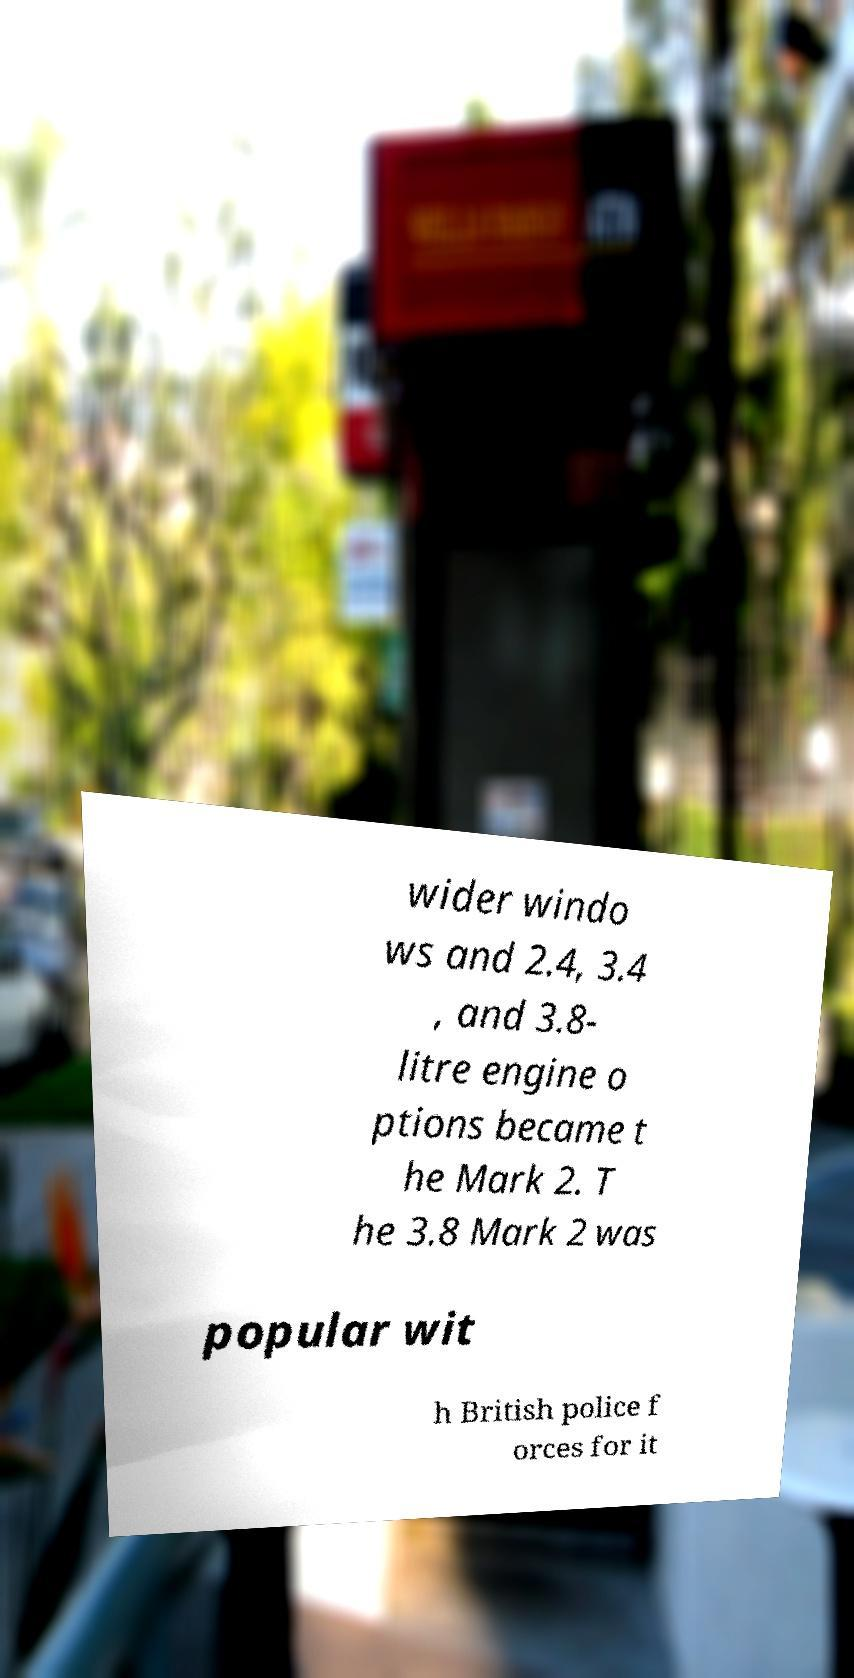For documentation purposes, I need the text within this image transcribed. Could you provide that? wider windo ws and 2.4, 3.4 , and 3.8- litre engine o ptions became t he Mark 2. T he 3.8 Mark 2 was popular wit h British police f orces for it 